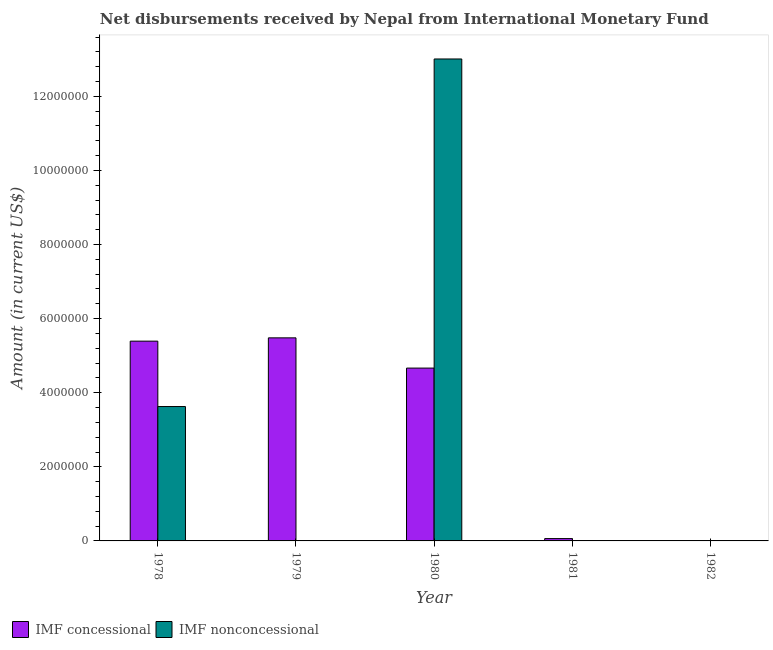How many bars are there on the 4th tick from the right?
Offer a very short reply. 1. What is the label of the 3rd group of bars from the left?
Provide a succinct answer. 1980. In how many cases, is the number of bars for a given year not equal to the number of legend labels?
Provide a succinct answer. 3. What is the net non concessional disbursements from imf in 1978?
Keep it short and to the point. 3.63e+06. Across all years, what is the maximum net non concessional disbursements from imf?
Keep it short and to the point. 1.30e+07. Across all years, what is the minimum net non concessional disbursements from imf?
Keep it short and to the point. 0. In which year was the net non concessional disbursements from imf maximum?
Your answer should be very brief. 1980. What is the total net concessional disbursements from imf in the graph?
Offer a very short reply. 1.56e+07. What is the difference between the net concessional disbursements from imf in 1978 and that in 1980?
Your response must be concise. 7.27e+05. What is the difference between the net non concessional disbursements from imf in 1978 and the net concessional disbursements from imf in 1980?
Ensure brevity in your answer.  -9.38e+06. What is the average net non concessional disbursements from imf per year?
Offer a terse response. 3.33e+06. What is the ratio of the net concessional disbursements from imf in 1979 to that in 1980?
Keep it short and to the point. 1.17. What is the difference between the highest and the second highest net concessional disbursements from imf?
Provide a short and direct response. 8.90e+04. What is the difference between the highest and the lowest net non concessional disbursements from imf?
Your response must be concise. 1.30e+07. Is the sum of the net concessional disbursements from imf in 1978 and 1981 greater than the maximum net non concessional disbursements from imf across all years?
Your answer should be very brief. No. How many bars are there?
Your answer should be compact. 6. What is the difference between two consecutive major ticks on the Y-axis?
Make the answer very short. 2.00e+06. Does the graph contain any zero values?
Provide a succinct answer. Yes. What is the title of the graph?
Ensure brevity in your answer.  Net disbursements received by Nepal from International Monetary Fund. What is the label or title of the X-axis?
Your answer should be compact. Year. What is the Amount (in current US$) of IMF concessional in 1978?
Your response must be concise. 5.39e+06. What is the Amount (in current US$) of IMF nonconcessional in 1978?
Offer a very short reply. 3.63e+06. What is the Amount (in current US$) of IMF concessional in 1979?
Provide a succinct answer. 5.48e+06. What is the Amount (in current US$) in IMF nonconcessional in 1979?
Give a very brief answer. 0. What is the Amount (in current US$) of IMF concessional in 1980?
Provide a succinct answer. 4.66e+06. What is the Amount (in current US$) of IMF nonconcessional in 1980?
Give a very brief answer. 1.30e+07. What is the Amount (in current US$) of IMF concessional in 1981?
Keep it short and to the point. 6.30e+04. What is the Amount (in current US$) in IMF nonconcessional in 1982?
Make the answer very short. 0. Across all years, what is the maximum Amount (in current US$) in IMF concessional?
Keep it short and to the point. 5.48e+06. Across all years, what is the maximum Amount (in current US$) in IMF nonconcessional?
Make the answer very short. 1.30e+07. Across all years, what is the minimum Amount (in current US$) of IMF concessional?
Your answer should be very brief. 0. Across all years, what is the minimum Amount (in current US$) of IMF nonconcessional?
Offer a terse response. 0. What is the total Amount (in current US$) in IMF concessional in the graph?
Your answer should be very brief. 1.56e+07. What is the total Amount (in current US$) in IMF nonconcessional in the graph?
Ensure brevity in your answer.  1.66e+07. What is the difference between the Amount (in current US$) in IMF concessional in 1978 and that in 1979?
Offer a very short reply. -8.90e+04. What is the difference between the Amount (in current US$) in IMF concessional in 1978 and that in 1980?
Offer a terse response. 7.27e+05. What is the difference between the Amount (in current US$) in IMF nonconcessional in 1978 and that in 1980?
Your answer should be very brief. -9.38e+06. What is the difference between the Amount (in current US$) of IMF concessional in 1978 and that in 1981?
Your response must be concise. 5.33e+06. What is the difference between the Amount (in current US$) in IMF concessional in 1979 and that in 1980?
Make the answer very short. 8.16e+05. What is the difference between the Amount (in current US$) of IMF concessional in 1979 and that in 1981?
Your answer should be compact. 5.42e+06. What is the difference between the Amount (in current US$) in IMF concessional in 1980 and that in 1981?
Ensure brevity in your answer.  4.60e+06. What is the difference between the Amount (in current US$) of IMF concessional in 1978 and the Amount (in current US$) of IMF nonconcessional in 1980?
Provide a succinct answer. -7.62e+06. What is the difference between the Amount (in current US$) of IMF concessional in 1979 and the Amount (in current US$) of IMF nonconcessional in 1980?
Give a very brief answer. -7.53e+06. What is the average Amount (in current US$) of IMF concessional per year?
Offer a very short reply. 3.12e+06. What is the average Amount (in current US$) of IMF nonconcessional per year?
Provide a short and direct response. 3.33e+06. In the year 1978, what is the difference between the Amount (in current US$) of IMF concessional and Amount (in current US$) of IMF nonconcessional?
Offer a very short reply. 1.76e+06. In the year 1980, what is the difference between the Amount (in current US$) of IMF concessional and Amount (in current US$) of IMF nonconcessional?
Make the answer very short. -8.34e+06. What is the ratio of the Amount (in current US$) in IMF concessional in 1978 to that in 1979?
Provide a succinct answer. 0.98. What is the ratio of the Amount (in current US$) of IMF concessional in 1978 to that in 1980?
Your answer should be very brief. 1.16. What is the ratio of the Amount (in current US$) of IMF nonconcessional in 1978 to that in 1980?
Ensure brevity in your answer.  0.28. What is the ratio of the Amount (in current US$) of IMF concessional in 1978 to that in 1981?
Give a very brief answer. 85.59. What is the ratio of the Amount (in current US$) of IMF concessional in 1979 to that in 1980?
Keep it short and to the point. 1.17. What is the ratio of the Amount (in current US$) of IMF concessional in 1979 to that in 1981?
Ensure brevity in your answer.  87. What is the ratio of the Amount (in current US$) in IMF concessional in 1980 to that in 1981?
Provide a short and direct response. 74.05. What is the difference between the highest and the second highest Amount (in current US$) in IMF concessional?
Your response must be concise. 8.90e+04. What is the difference between the highest and the lowest Amount (in current US$) in IMF concessional?
Keep it short and to the point. 5.48e+06. What is the difference between the highest and the lowest Amount (in current US$) of IMF nonconcessional?
Your response must be concise. 1.30e+07. 